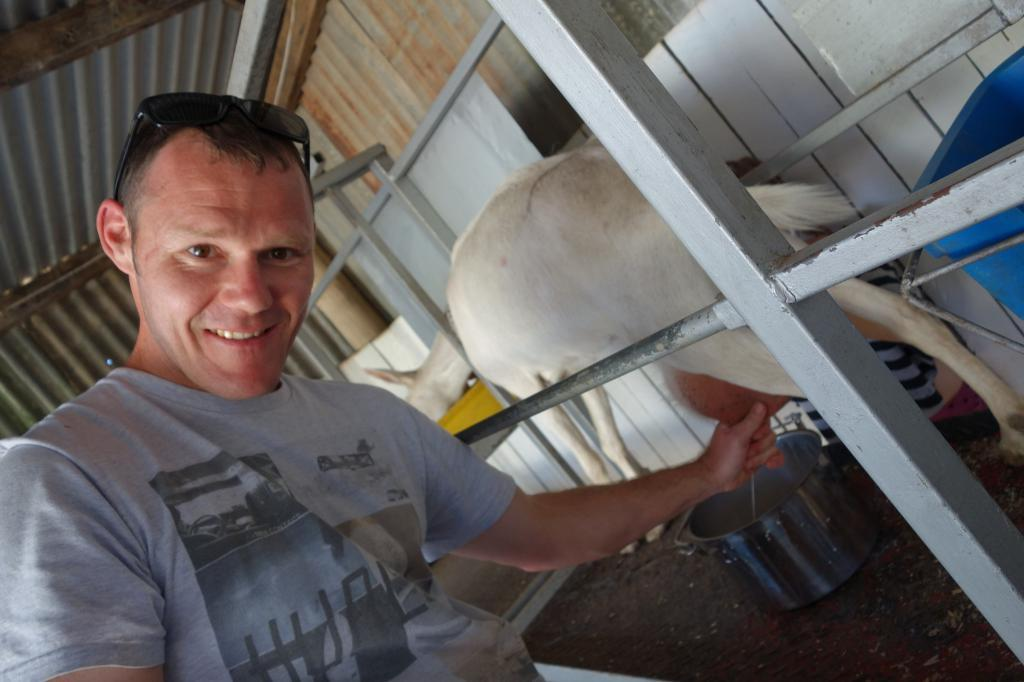Where was the picture taken? The picture was taken in a stable. What can be seen in the foreground of the image? There is a person in the foreground of the image. What is the main subject in the center of the image? There is an animal in the center of the image. What type of structure is visible at the top of the image? There is an iron shed at the top of the image. What book is the person reading to the animal in the image? There is no book present in the image, and the person is not reading to the animal. 